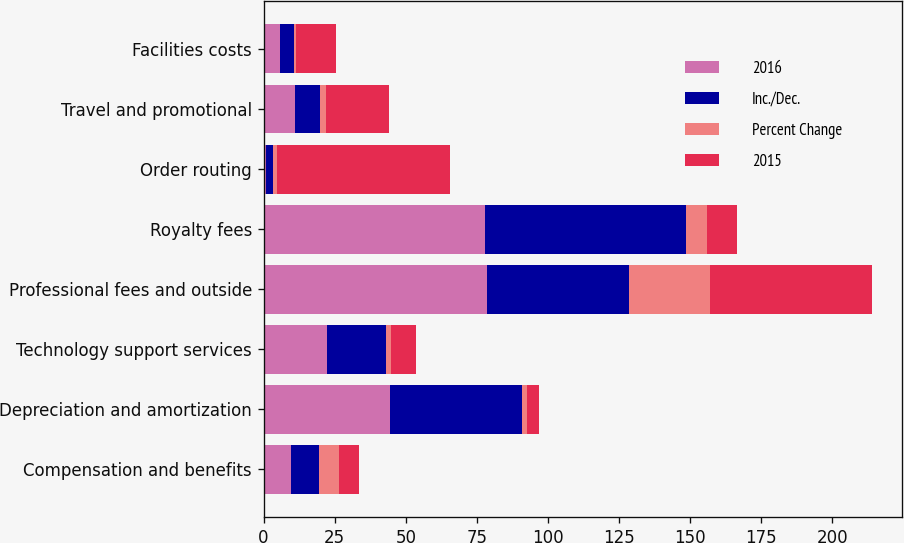Convert chart. <chart><loc_0><loc_0><loc_500><loc_500><stacked_bar_chart><ecel><fcel>Compensation and benefits<fcel>Depreciation and amortization<fcel>Technology support services<fcel>Professional fees and outside<fcel>Royalty fees<fcel>Order routing<fcel>Travel and promotional<fcel>Facilities costs<nl><fcel>2016<fcel>9.7<fcel>44.4<fcel>22.4<fcel>78.5<fcel>77.9<fcel>0.9<fcel>11<fcel>5.7<nl><fcel>Inc./Dec.<fcel>9.7<fcel>46.3<fcel>20.7<fcel>50.1<fcel>70.6<fcel>2.3<fcel>8.9<fcel>5<nl><fcel>Percent Change<fcel>7.3<fcel>1.9<fcel>1.7<fcel>28.4<fcel>7.3<fcel>1.4<fcel>2.1<fcel>0.7<nl><fcel>2015<fcel>6.8<fcel>4.1<fcel>8.7<fcel>56.9<fcel>10.5<fcel>60.8<fcel>22.1<fcel>13.9<nl></chart> 